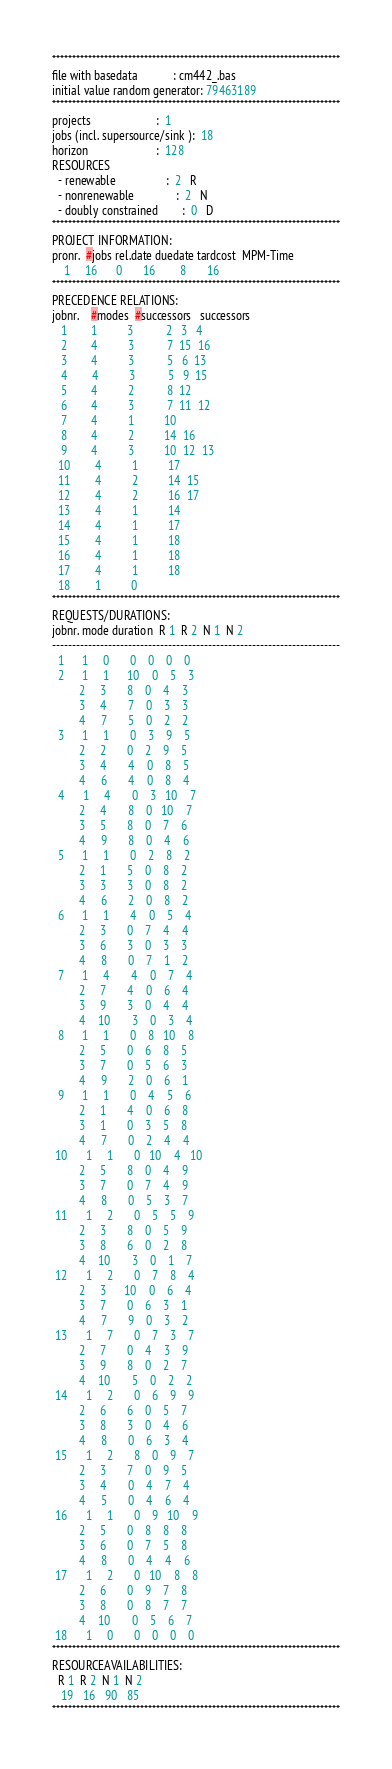<code> <loc_0><loc_0><loc_500><loc_500><_ObjectiveC_>************************************************************************
file with basedata            : cm442_.bas
initial value random generator: 79463189
************************************************************************
projects                      :  1
jobs (incl. supersource/sink ):  18
horizon                       :  128
RESOURCES
  - renewable                 :  2   R
  - nonrenewable              :  2   N
  - doubly constrained        :  0   D
************************************************************************
PROJECT INFORMATION:
pronr.  #jobs rel.date duedate tardcost  MPM-Time
    1     16      0       16        8       16
************************************************************************
PRECEDENCE RELATIONS:
jobnr.    #modes  #successors   successors
   1        1          3           2   3   4
   2        4          3           7  15  16
   3        4          3           5   6  13
   4        4          3           5   9  15
   5        4          2           8  12
   6        4          3           7  11  12
   7        4          1          10
   8        4          2          14  16
   9        4          3          10  12  13
  10        4          1          17
  11        4          2          14  15
  12        4          2          16  17
  13        4          1          14
  14        4          1          17
  15        4          1          18
  16        4          1          18
  17        4          1          18
  18        1          0        
************************************************************************
REQUESTS/DURATIONS:
jobnr. mode duration  R 1  R 2  N 1  N 2
------------------------------------------------------------------------
  1      1     0       0    0    0    0
  2      1     1      10    0    5    3
         2     3       8    0    4    3
         3     4       7    0    3    3
         4     7       5    0    2    2
  3      1     1       0    3    9    5
         2     2       0    2    9    5
         3     4       4    0    8    5
         4     6       4    0    8    4
  4      1     4       0    3   10    7
         2     4       8    0   10    7
         3     5       8    0    7    6
         4     9       8    0    4    6
  5      1     1       0    2    8    2
         2     1       5    0    8    2
         3     3       3    0    8    2
         4     6       2    0    8    2
  6      1     1       4    0    5    4
         2     3       0    7    4    4
         3     6       3    0    3    3
         4     8       0    7    1    2
  7      1     4       4    0    7    4
         2     7       4    0    6    4
         3     9       3    0    4    4
         4    10       3    0    3    4
  8      1     1       0    8   10    8
         2     5       0    6    8    5
         3     7       0    5    6    3
         4     9       2    0    6    1
  9      1     1       0    4    5    6
         2     1       4    0    6    8
         3     1       0    3    5    8
         4     7       0    2    4    4
 10      1     1       0   10    4   10
         2     5       8    0    4    9
         3     7       0    7    4    9
         4     8       0    5    3    7
 11      1     2       0    5    5    9
         2     3       8    0    5    9
         3     8       6    0    2    8
         4    10       3    0    1    7
 12      1     2       0    7    8    4
         2     3      10    0    6    4
         3     7       0    6    3    1
         4     7       9    0    3    2
 13      1     7       0    7    3    7
         2     7       0    4    3    9
         3     9       8    0    2    7
         4    10       5    0    2    2
 14      1     2       0    6    9    9
         2     6       6    0    5    7
         3     8       3    0    4    6
         4     8       0    6    3    4
 15      1     2       8    0    9    7
         2     3       7    0    9    5
         3     4       0    4    7    4
         4     5       0    4    6    4
 16      1     1       0    9   10    9
         2     5       0    8    8    8
         3     6       0    7    5    8
         4     8       0    4    4    6
 17      1     2       0   10    8    8
         2     6       0    9    7    8
         3     8       0    8    7    7
         4    10       0    5    6    7
 18      1     0       0    0    0    0
************************************************************************
RESOURCEAVAILABILITIES:
  R 1  R 2  N 1  N 2
   19   16   90   85
************************************************************************
</code> 